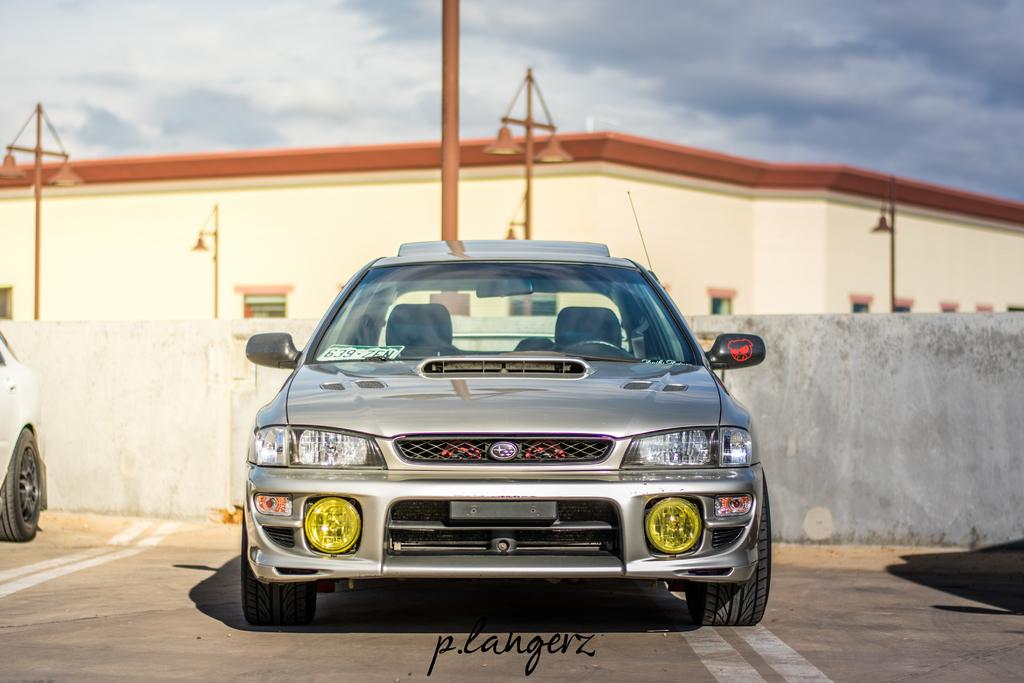How many vehicles are present on the ground in the image? There are two vehicles on the ground in the image. What else can be seen in the image besides the vehicles? There are poles, lights, windows, and a building in the image. What is visible in the background of the image? The sky with clouds is visible in the background of the image. How many passengers are on the island in the image? There is no island present in the image. Can you describe the person walking near the vehicles in the image? There is no person walking near the vehicles in the image. 